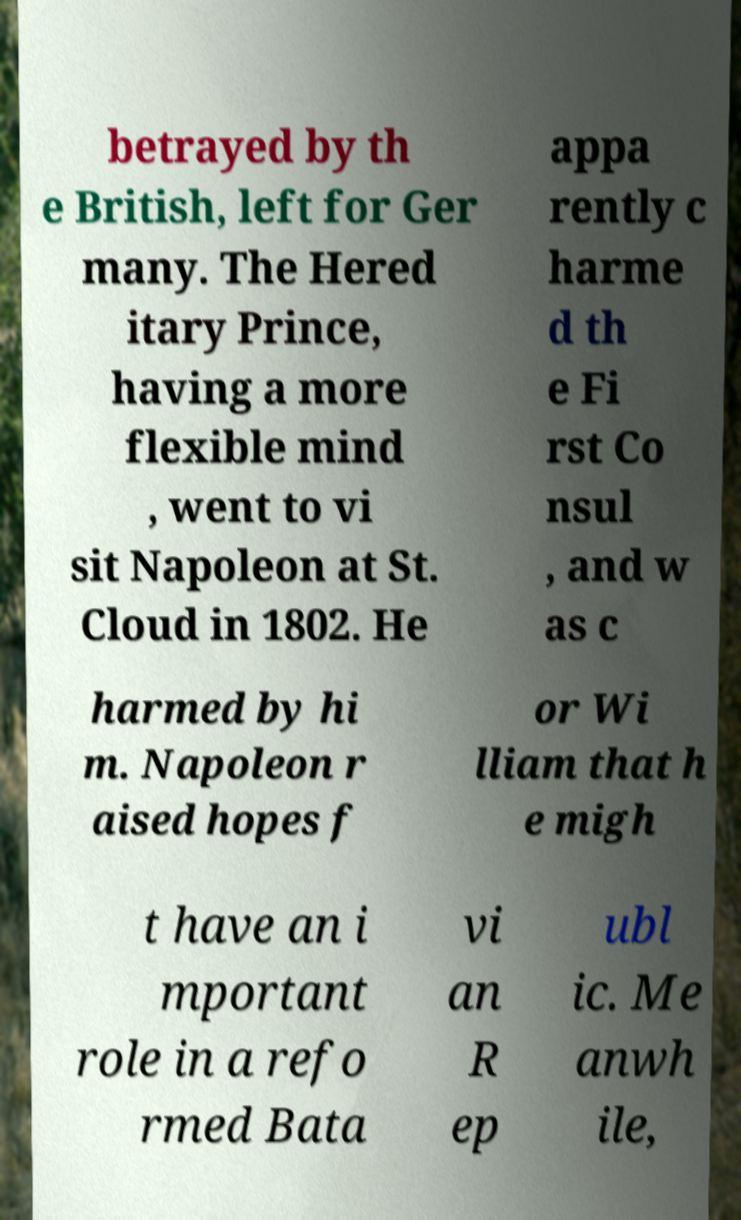I need the written content from this picture converted into text. Can you do that? betrayed by th e British, left for Ger many. The Hered itary Prince, having a more flexible mind , went to vi sit Napoleon at St. Cloud in 1802. He appa rently c harme d th e Fi rst Co nsul , and w as c harmed by hi m. Napoleon r aised hopes f or Wi lliam that h e migh t have an i mportant role in a refo rmed Bata vi an R ep ubl ic. Me anwh ile, 